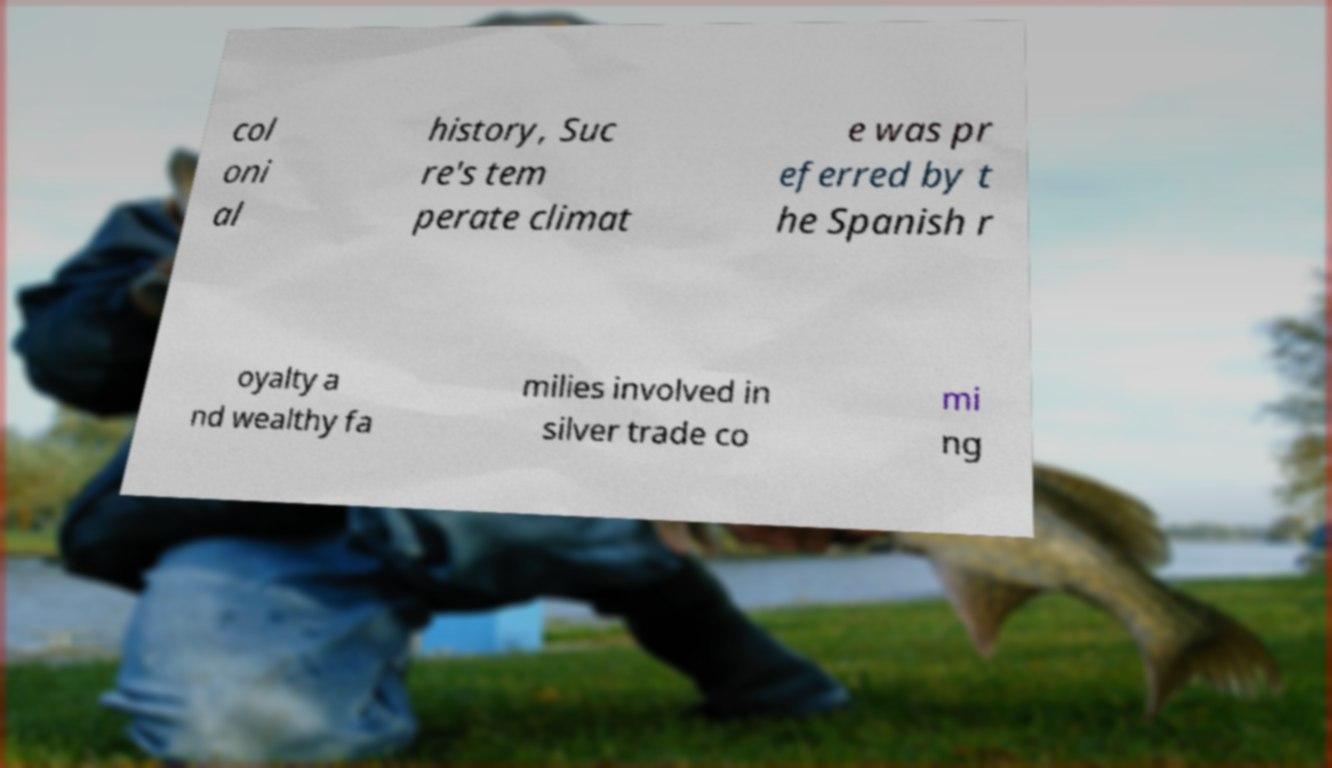There's text embedded in this image that I need extracted. Can you transcribe it verbatim? col oni al history, Suc re's tem perate climat e was pr eferred by t he Spanish r oyalty a nd wealthy fa milies involved in silver trade co mi ng 